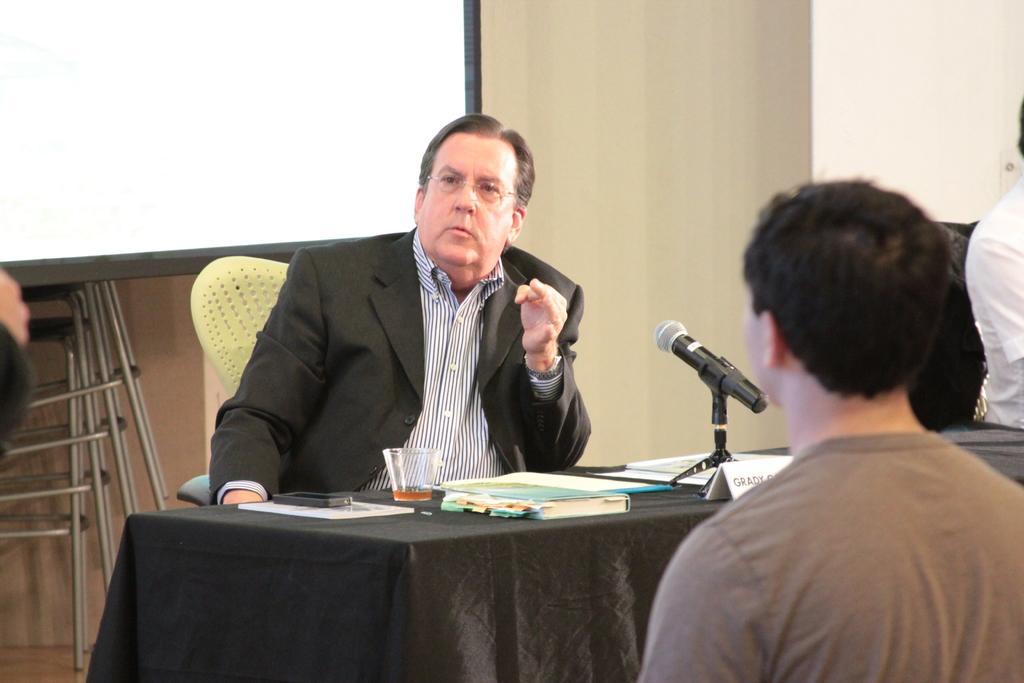Please provide a concise description of this image. In this picture we can see three people and here we can see this guy sitting on a chair in front of a table with a microphone and books and a glass of wine on it, there is a board behind him 